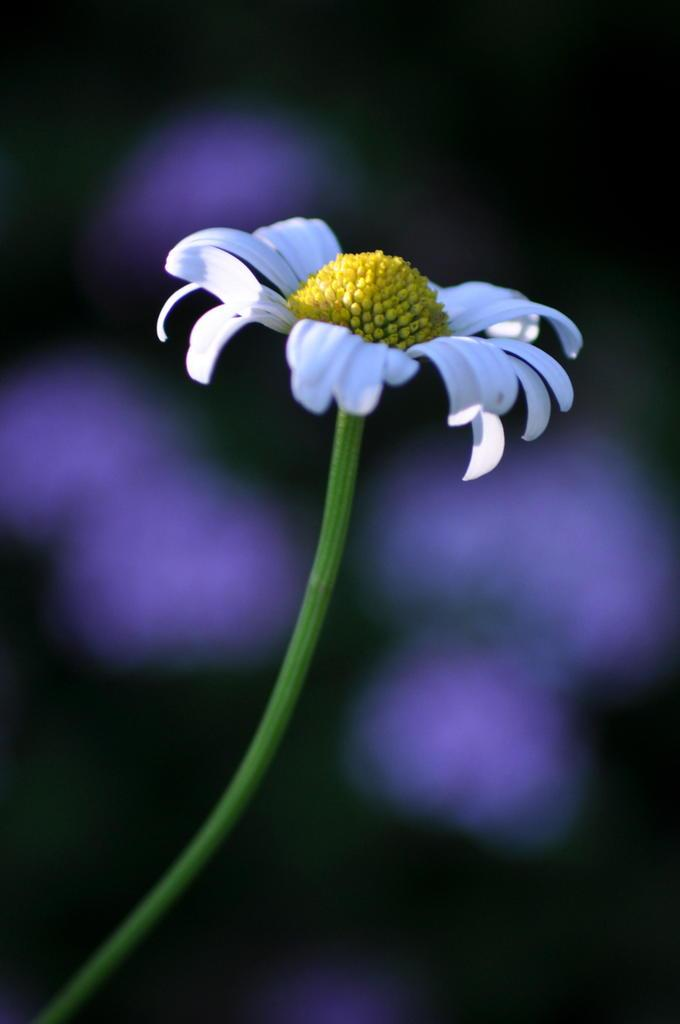What is the main subject of the image? There is a flower in the image. What colors can be seen on the flower? The flower has white and yellow colors. What is the flower attached to? The flower is on a green stem. How would you describe the background of the image? The background of the image is blurred. Can you see any cobwebs in the image? There is no mention of cobwebs in the image, so we cannot determine if they are present or not. 